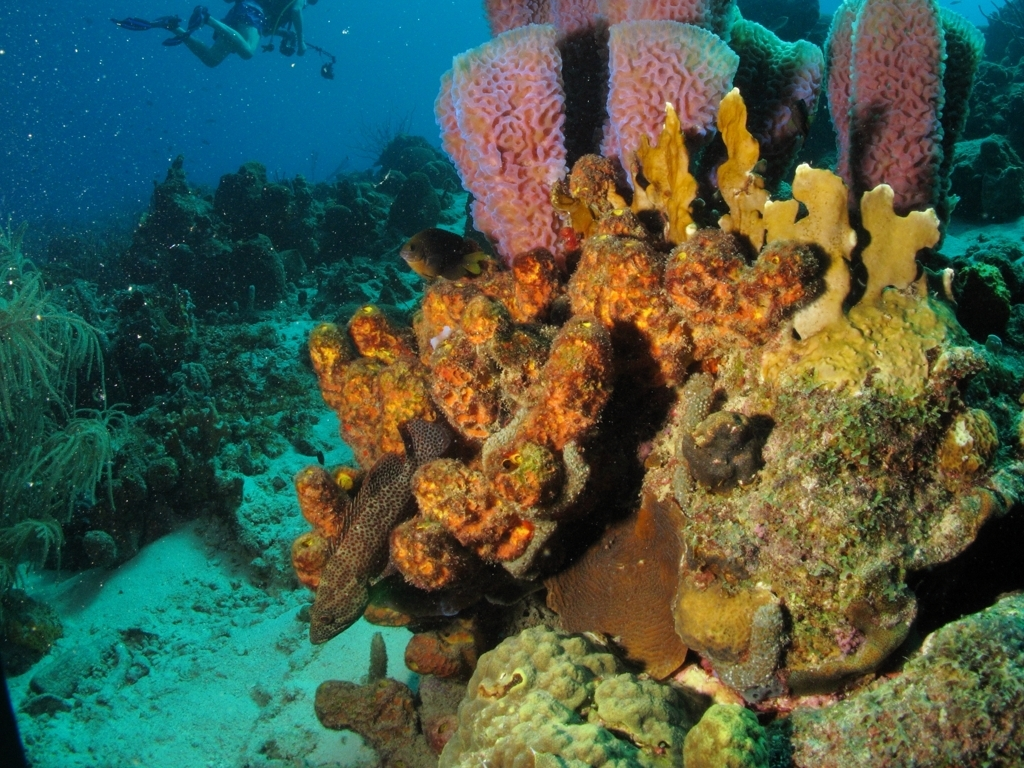Can you tell me more about the types of coral in this picture? Certainly! The image features several different types of coral. For instance, we can observe the large, fan-like structures that are likely sea fans, which are a type of soft coral. There are also brain corals visible, recognizable by their grooved, brain-like appearance. The diversity of coral species in this image is indicative of a healthy reef ecosystem. 